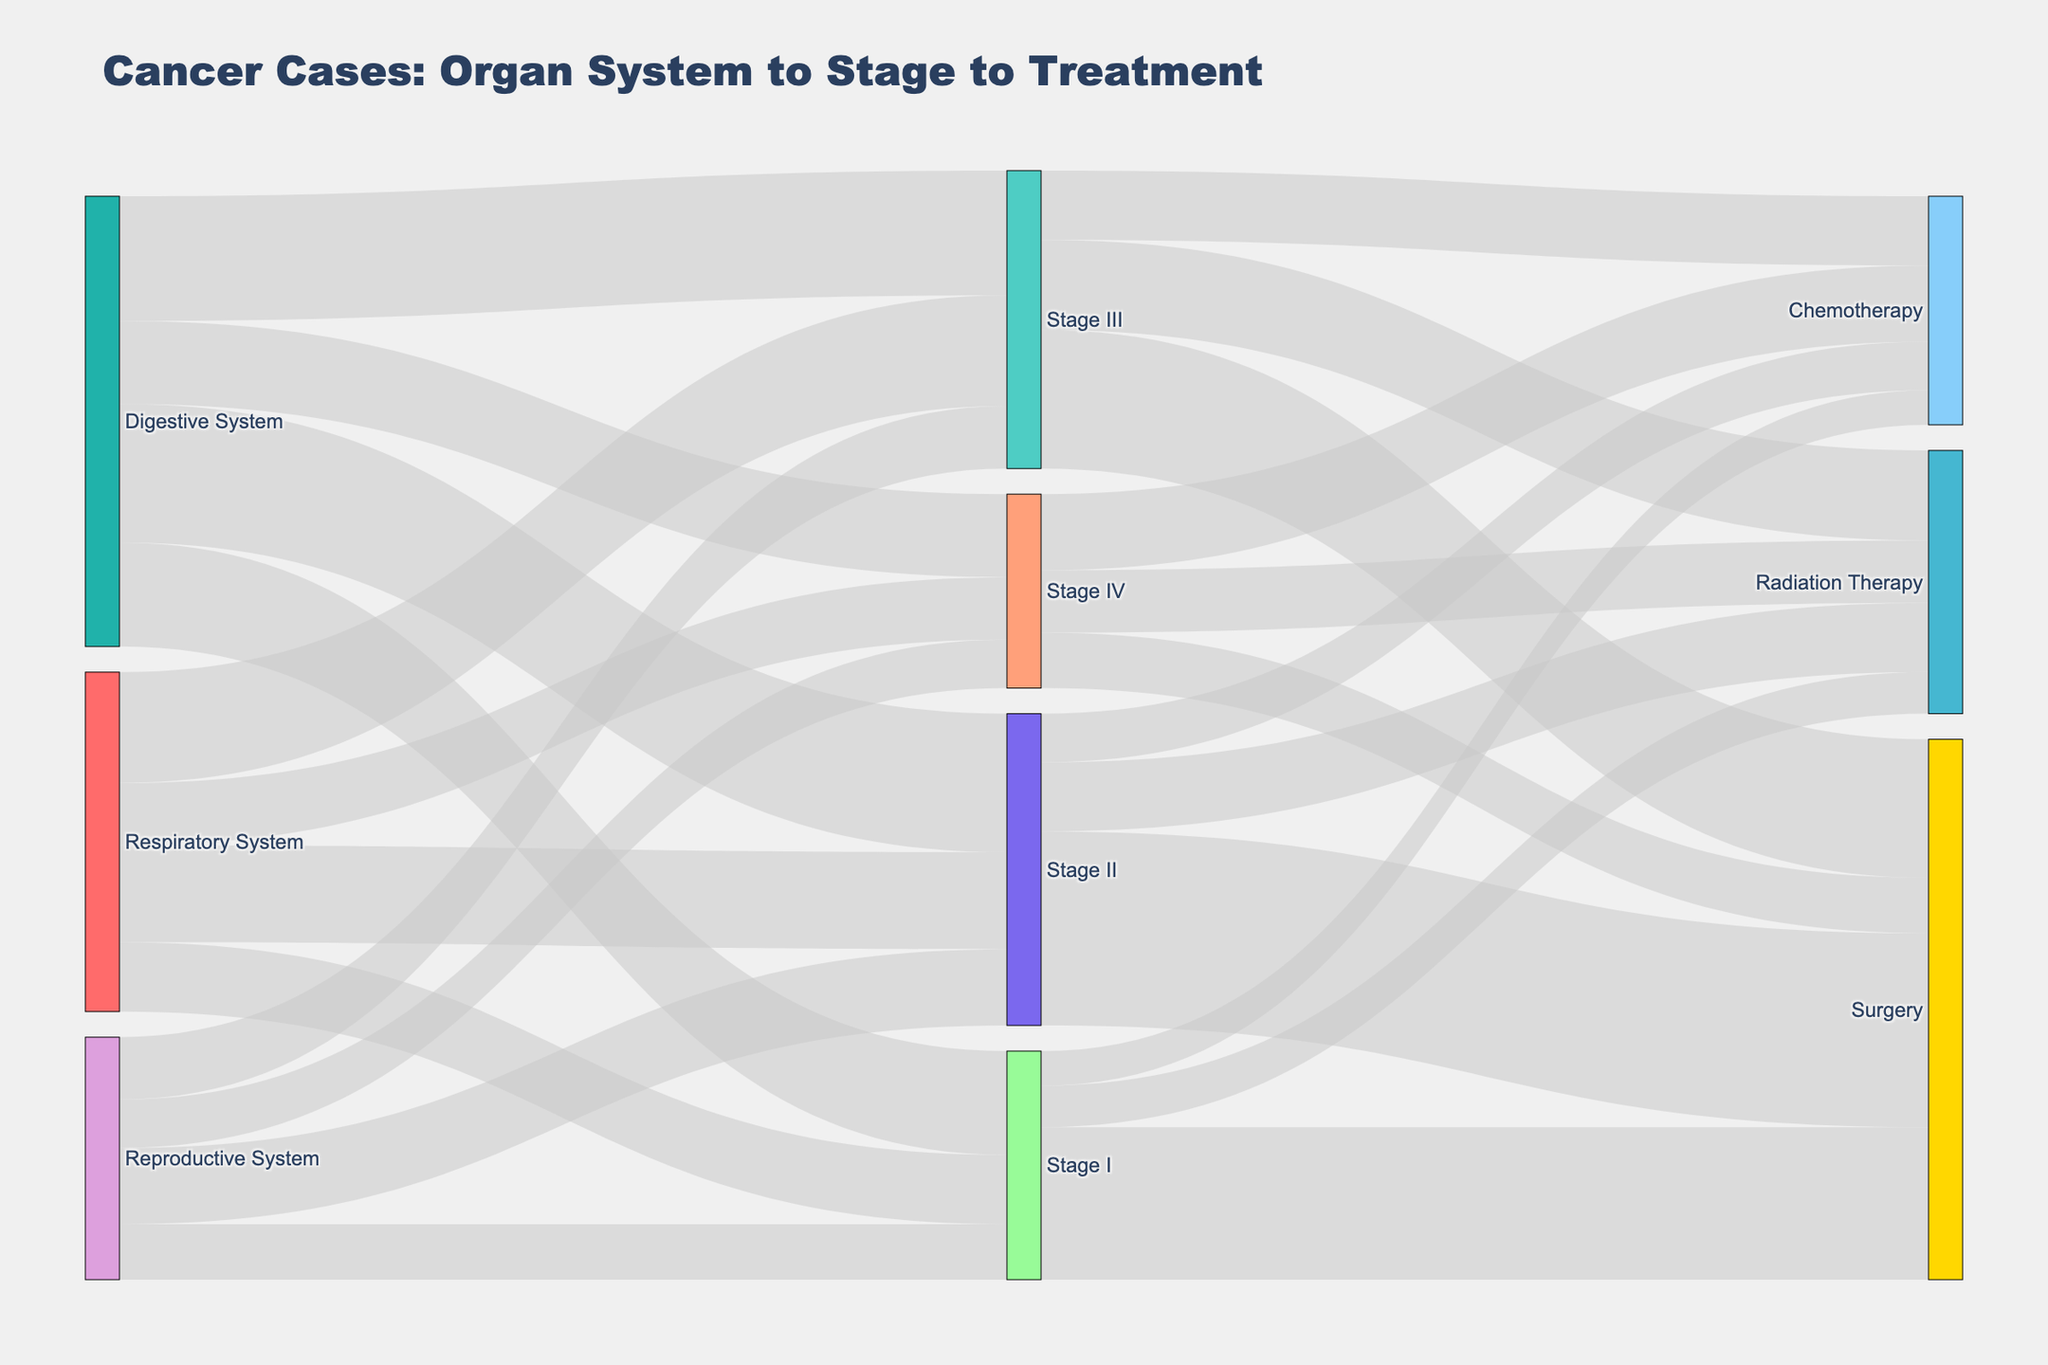What is the total number of cancer cases in the Digestive System? Add up the number of cases in each stage of the Digestive System: 150 (Stage I) + 200 (Stage II) + 180 (Stage III) + 120 (Stage IV) = 650.
Answer: 650 Which treatment modality is the most common for Stage III cases? Compare the values for Stage III cases: Surgery (200), Radiation Therapy (130), Chemotherapy (100). Surgery has the highest value.
Answer: Surgery How many cancer cases in total are treated with Chemotherapy? Add up the cases treated with Chemotherapy in each stage: 50 (Stage I) + 70 (Stage II) + 100 (Stage III) + 110 (Stage IV) = 330.
Answer: 330 What is the least common stage at diagnosis for the Respiratory System? Compare the values for each stage of the Respiratory System: Stage I (100), Stage II (140), Stage III (160), Stage IV (90). Stage IV has the lowest value.
Answer: Stage IV How many total cancer cases are initially diagnosed at Stage II? Add up the number of cases diagnosed at Stage II for each organ system: Digestive System (200) + Respiratory System (140) + Reproductive System (110) = 450.
Answer: 450 Which organ system has the highest number of Stage I cases? Compare the Stage I values for each organ system: Digestive System (150), Respiratory System (100), Reproductive System (80). The Digestive System has the highest value.
Answer: Digestive System Which treatment modality is least common for Stage IV cases? Compare the values for Stage IV cases: Surgery (80), Radiation Therapy (90), Chemotherapy (110). Surgery has the lowest value.
Answer: Surgery Between which stages and treatment modalities is the largest number of cancer cases observed? Identify the highest value among all stage and treatment modality combinations: The highest value is for Stage II to Surgery with 280 cases.
Answer: Stage II to Surgery What is the difference in the number of cases between Surgery and Chemotherapy for Stage I? Subtract the number of Stage I Chemotherapy cases from Stage I Surgery cases: 220 (Surgery) - 50 (Chemotherapy) = 170.
Answer: 170 How many cases in total are there in the Stage III category? Add up the cases from Stage III for all organ systems: Digestive System (180) + Respiratory System (160) + Reproductive System (90) = 430.
Answer: 430 